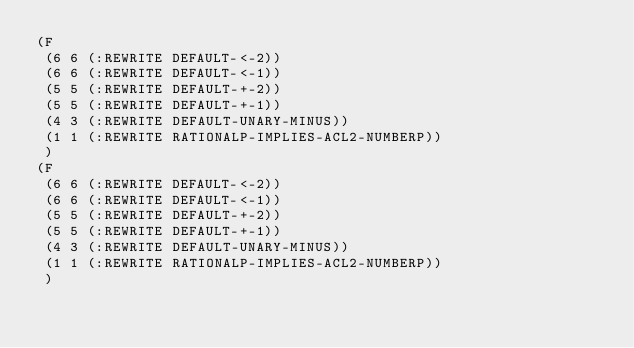Convert code to text. <code><loc_0><loc_0><loc_500><loc_500><_Lisp_>(F
 (6 6 (:REWRITE DEFAULT-<-2))
 (6 6 (:REWRITE DEFAULT-<-1))
 (5 5 (:REWRITE DEFAULT-+-2))
 (5 5 (:REWRITE DEFAULT-+-1))
 (4 3 (:REWRITE DEFAULT-UNARY-MINUS))
 (1 1 (:REWRITE RATIONALP-IMPLIES-ACL2-NUMBERP))
 )
(F
 (6 6 (:REWRITE DEFAULT-<-2))
 (6 6 (:REWRITE DEFAULT-<-1))
 (5 5 (:REWRITE DEFAULT-+-2))
 (5 5 (:REWRITE DEFAULT-+-1))
 (4 3 (:REWRITE DEFAULT-UNARY-MINUS))
 (1 1 (:REWRITE RATIONALP-IMPLIES-ACL2-NUMBERP))
 )
</code> 